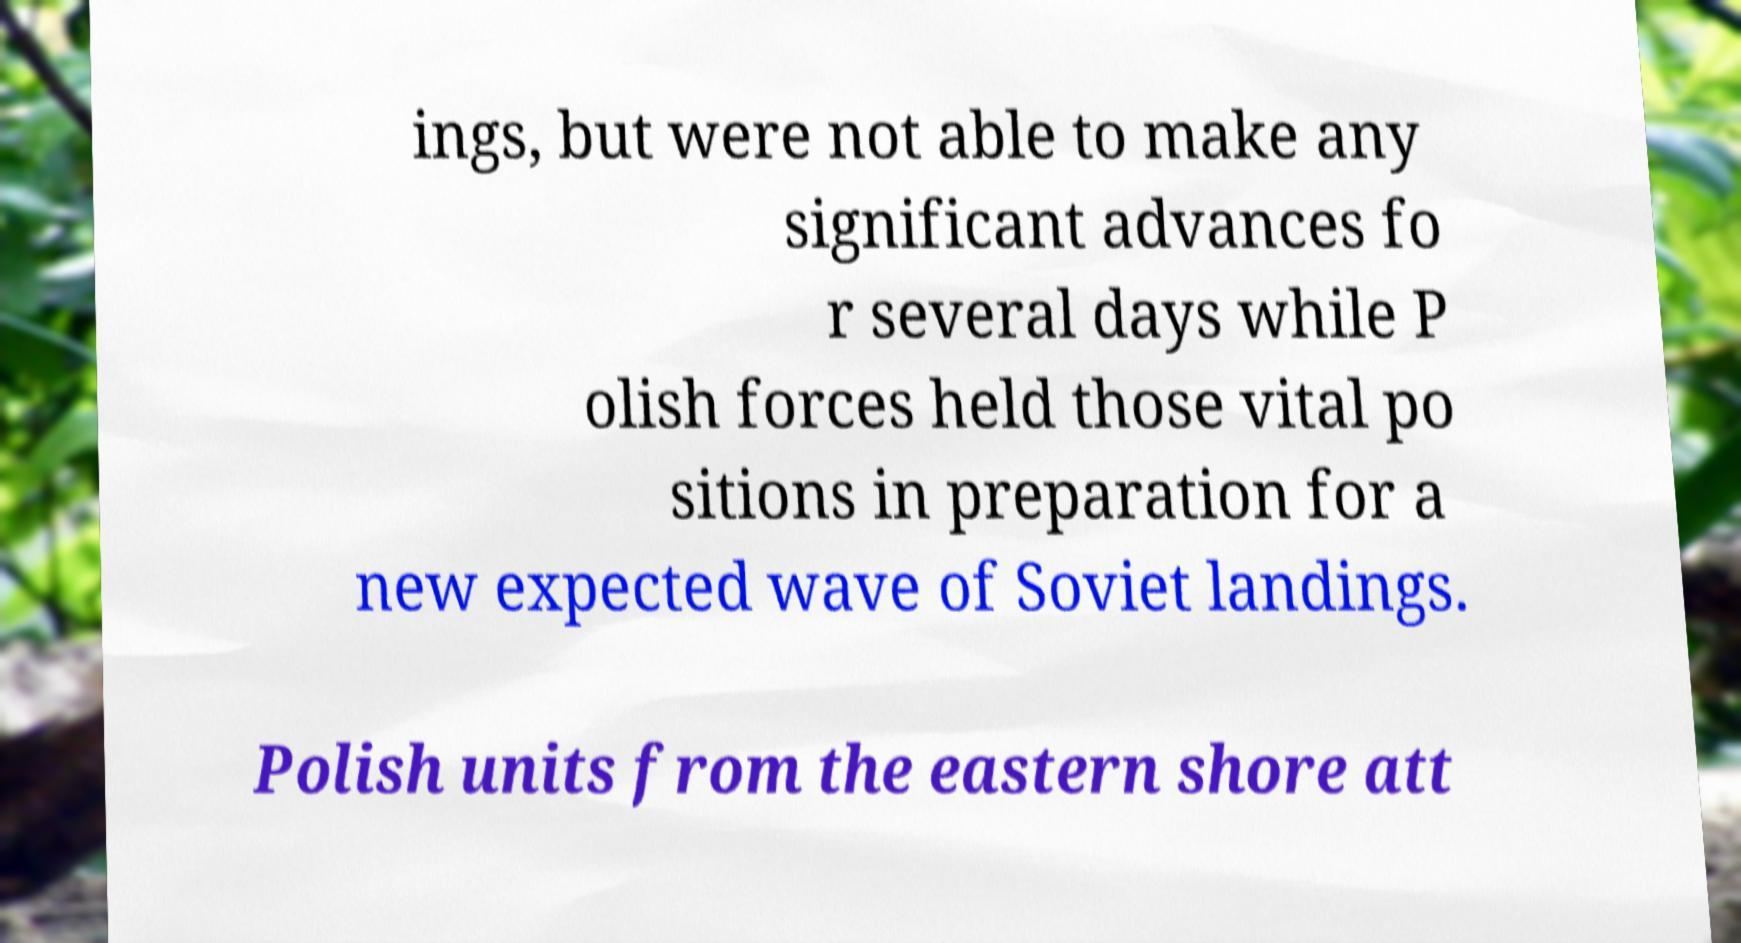I need the written content from this picture converted into text. Can you do that? ings, but were not able to make any significant advances fo r several days while P olish forces held those vital po sitions in preparation for a new expected wave of Soviet landings. Polish units from the eastern shore att 